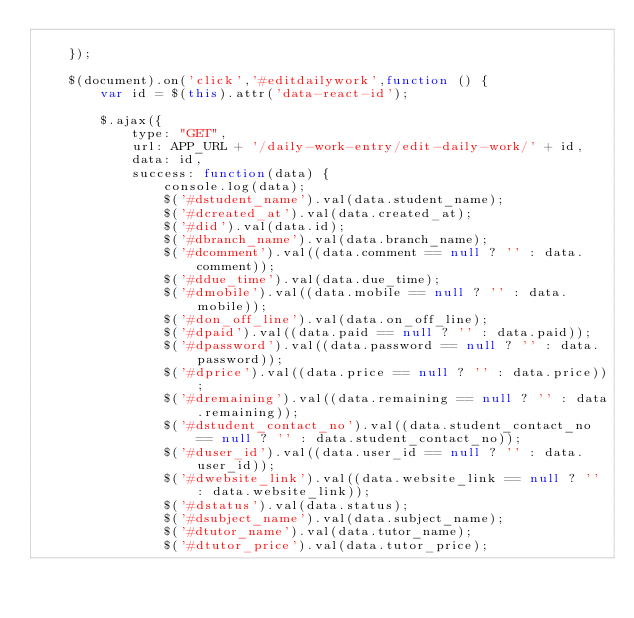<code> <loc_0><loc_0><loc_500><loc_500><_JavaScript_>
    });

    $(document).on('click','#editdailywork',function () {
        var id = $(this).attr('data-react-id');

        $.ajax({
            type: "GET",
            url: APP_URL + '/daily-work-entry/edit-daily-work/' + id,
            data: id,
            success: function(data) {
                console.log(data);
                $('#dstudent_name').val(data.student_name);
                $('#dcreated_at').val(data.created_at);
                $('#did').val(data.id);
                $('#dbranch_name').val(data.branch_name);
                $('#dcomment').val((data.comment == null ? '' : data.comment));
                $('#ddue_time').val(data.due_time);
                $('#dmobile').val((data.mobile == null ? '' : data.mobile));
                $('#don_off_line').val(data.on_off_line);
                $('#dpaid').val((data.paid == null ? '' : data.paid));
                $('#dpassword').val((data.password == null ? '' : data.password));
                $('#dprice').val((data.price == null ? '' : data.price));
                $('#dremaining').val((data.remaining == null ? '' : data.remaining));
                $('#dstudent_contact_no').val((data.student_contact_no == null ? '' : data.student_contact_no));
                $('#duser_id').val((data.user_id == null ? '' : data.user_id));
                $('#dwebsite_link').val((data.website_link == null ? '' : data.website_link));
                $('#dstatus').val(data.status);
                $('#dsubject_name').val(data.subject_name);
                $('#dtutor_name').val(data.tutor_name);
                $('#dtutor_price').val(data.tutor_price);</code> 